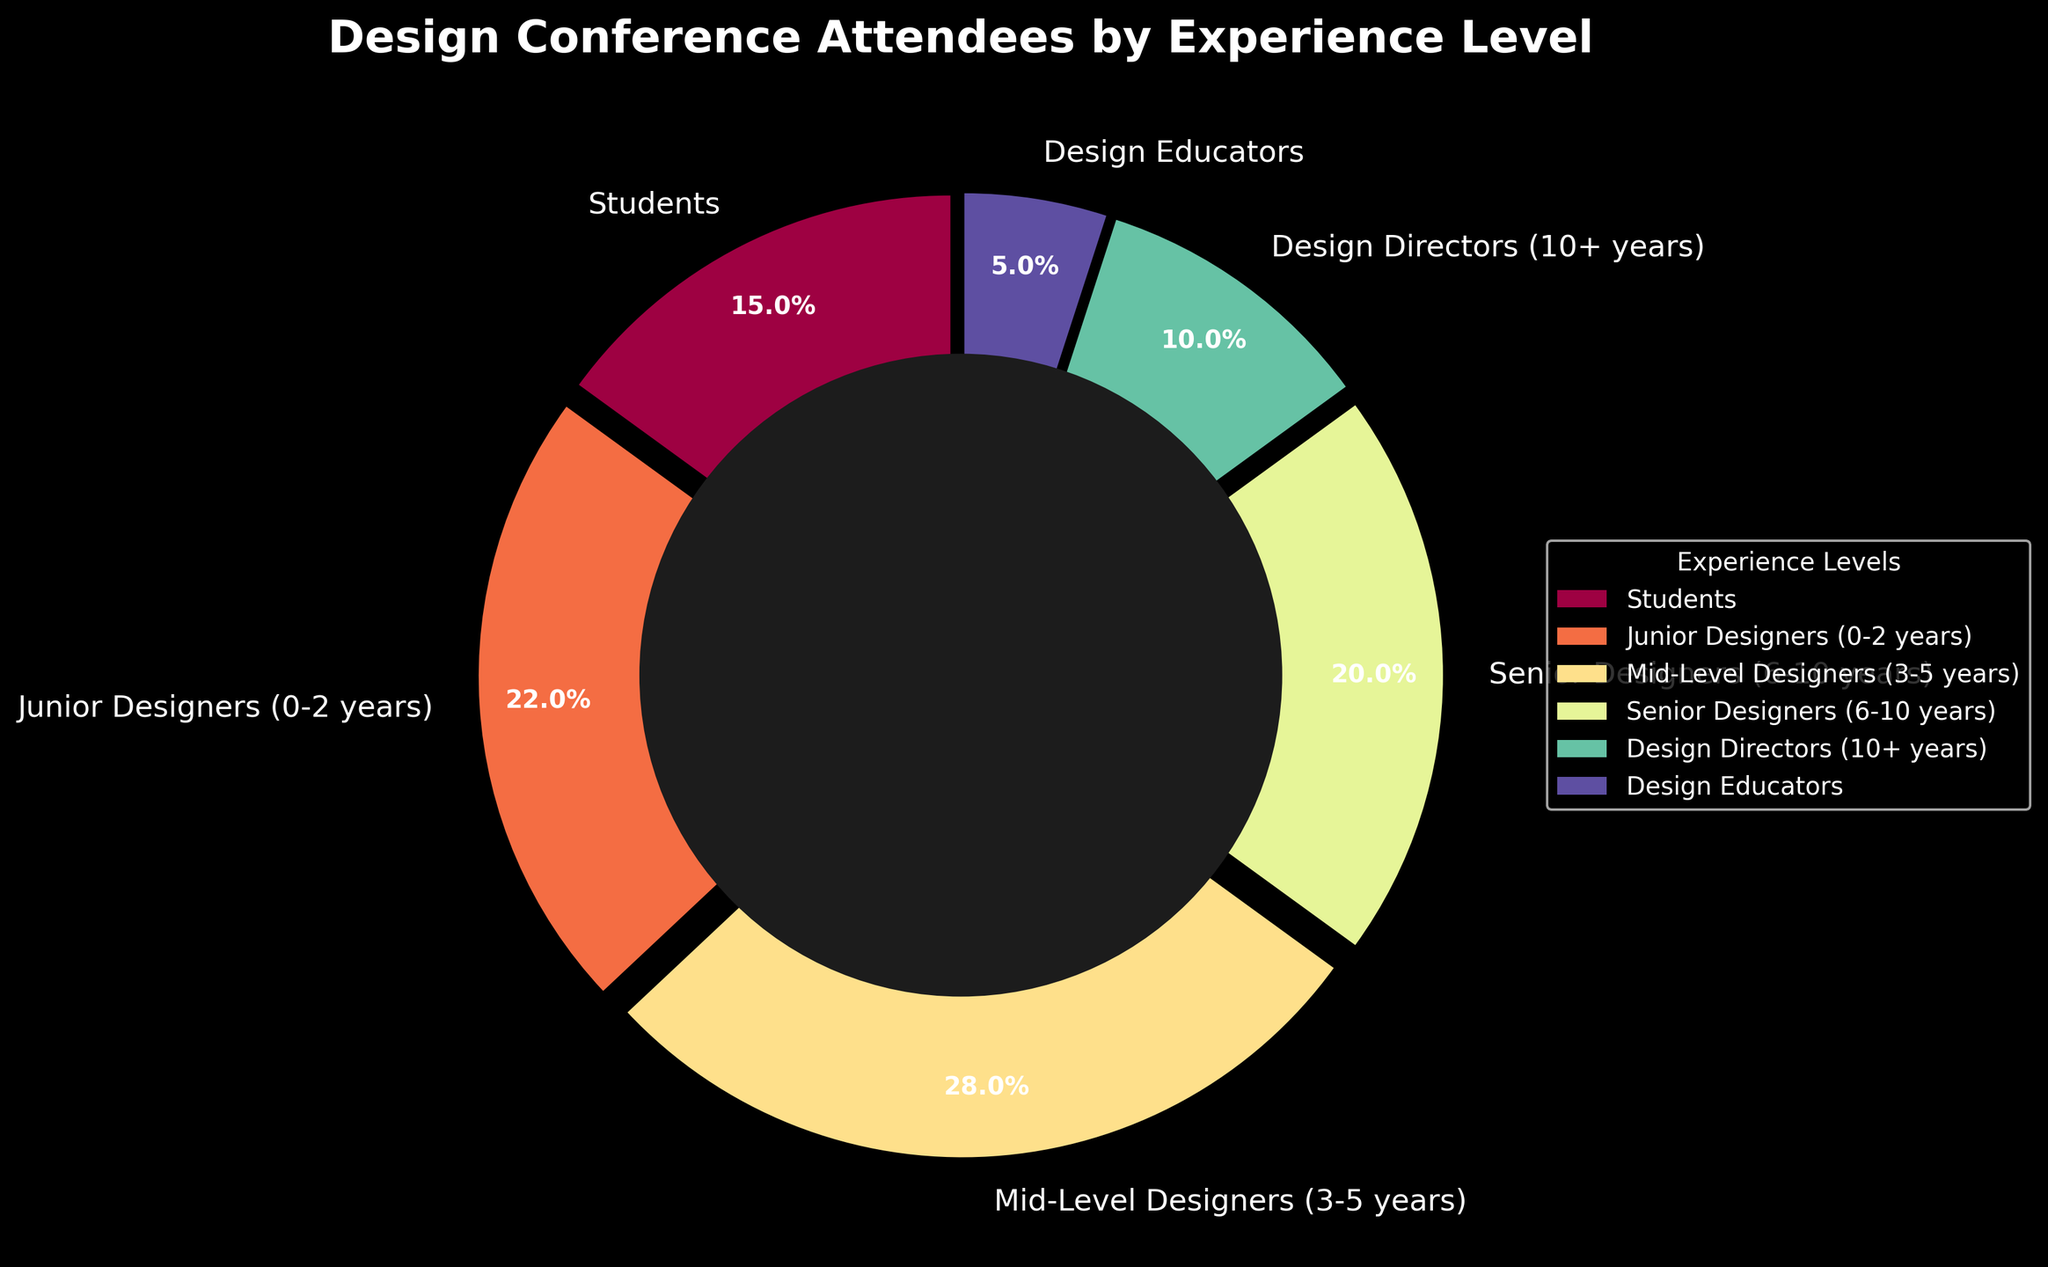What percentage of the conference attendees are students? The pie chart segment labeled "Students" shows the percentage of students among the conference attendees.
Answer: 15% Which experience level has the highest percentage of attendees? By comparing the size of the pie chart segments and their labels, we can see that "Mid-Level Designers (3-5 years)" has the largest segment.
Answer: Mid-Level Designers (3-5 years) Are there more Junior Designers (0-2 years) or Senior Designers (6-10 years) attending the conference? By comparing the segments labeled "Junior Designers (0-2 years)" and "Senior Designers (6-10 years)", we can observe that Junior Designers have a larger percentage.
Answer: Junior Designers (0-2 years) What is the total percentage of attendees with more than 5 years of experience (Senior Designers and Design Directors)? Add the percentages of "Senior Designers (6-10 years)" and "Design Directors (10+ years)": 20% + 10% = 30%.
Answer: 30% How does the percentage of Design Educators compare to the percentage of Students? By comparing the segments, we can see that the percentage of Design Educators (5%) is less than that of Students (15%).
Answer: Less than What is the combined percentage of Students and Junior Designers? Add the percentages of "Students" and "Junior Designers (0-2 years)": 15% + 22% = 37%.
Answer: 37% What is the difference in percentage between Mid-Level Designers and Design Directors? Subtract the percentage of "Design Directors (10+ years)" from that of "Mid-Level Designers (3-5 years)": 28% - 10% = 18%.
Answer: 18% Which experience levels are represented by blue color shades, and what are their corresponding percentages? Observe the segment colors and the associated experience levels. Blue shades typically correspond to "Senior Designers (6-10 years)" and "Design Directors (10+ years)" with percentages 20% and 10%, respectively.
Answer: Senior Designers (6-10 years): 20%, Design Directors (10+ years): 10% 